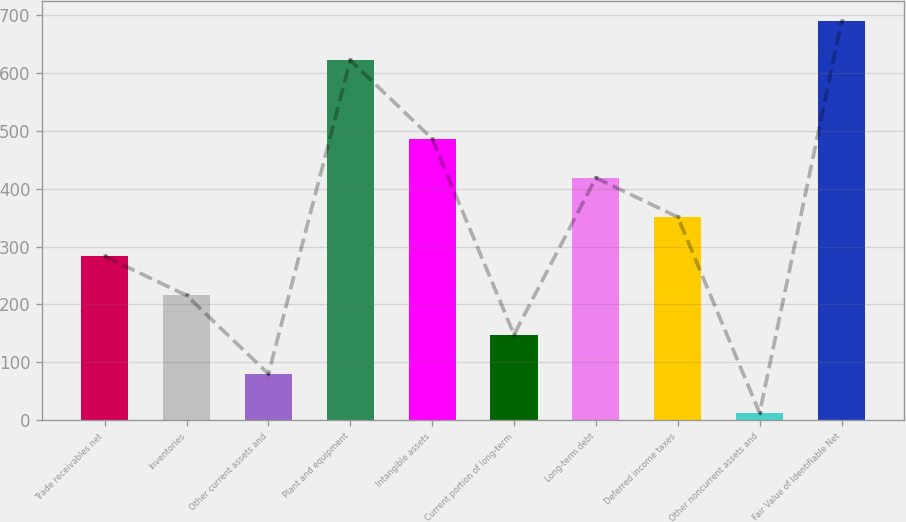<chart> <loc_0><loc_0><loc_500><loc_500><bar_chart><fcel>Trade receivables net<fcel>Inventories<fcel>Other current assets and<fcel>Plant and equipment<fcel>Intangible assets<fcel>Current portion of long-term<fcel>Long-term debt<fcel>Deferred income taxes<fcel>Other noncurrent assets and<fcel>Fair Value of Identifiable Net<nl><fcel>283.22<fcel>215.49<fcel>80.03<fcel>621.87<fcel>486.41<fcel>147.76<fcel>418.68<fcel>350.95<fcel>12.3<fcel>689.6<nl></chart> 